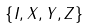Convert formula to latex. <formula><loc_0><loc_0><loc_500><loc_500>\left \{ I , X , Y , Z \right \}</formula> 